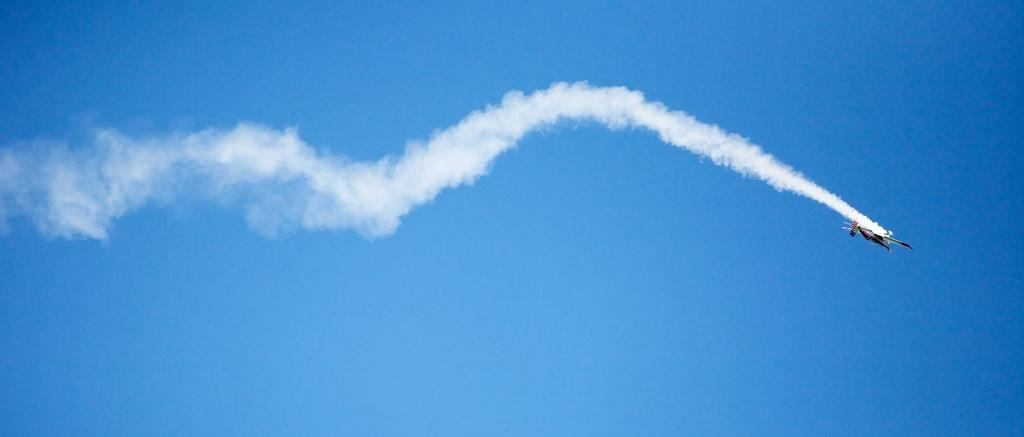What is the main subject of the image? The main subject of the image is an aircraft. Can you describe the position of the aircraft in the image? The aircraft is in the air in the image. What is the color of the smoke associated with the aircraft? The smoke associated with the aircraft is white. What can be seen in the background of the image? The sky is visible in the background of the image. What is the color of the sky in the image? The sky is blue in the image. What type of lock can be seen securing the aircraft in the image? There is no lock present in the image; the aircraft is in the air. What mark is visible on the wings of the aircraft in the image? There is no specific mark mentioned on the wings of the aircraft in the image. 